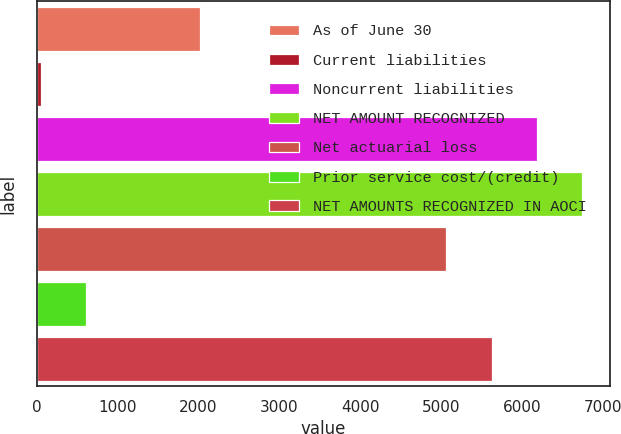<chart> <loc_0><loc_0><loc_500><loc_500><bar_chart><fcel>As of June 30<fcel>Current liabilities<fcel>Noncurrent liabilities<fcel>NET AMOUNT RECOGNIZED<fcel>Net actuarial loss<fcel>Prior service cost/(credit)<fcel>NET AMOUNTS RECOGNIZED IN AOCI<nl><fcel>2019<fcel>52<fcel>6182.6<fcel>6742.9<fcel>5062<fcel>612.3<fcel>5622.3<nl></chart> 